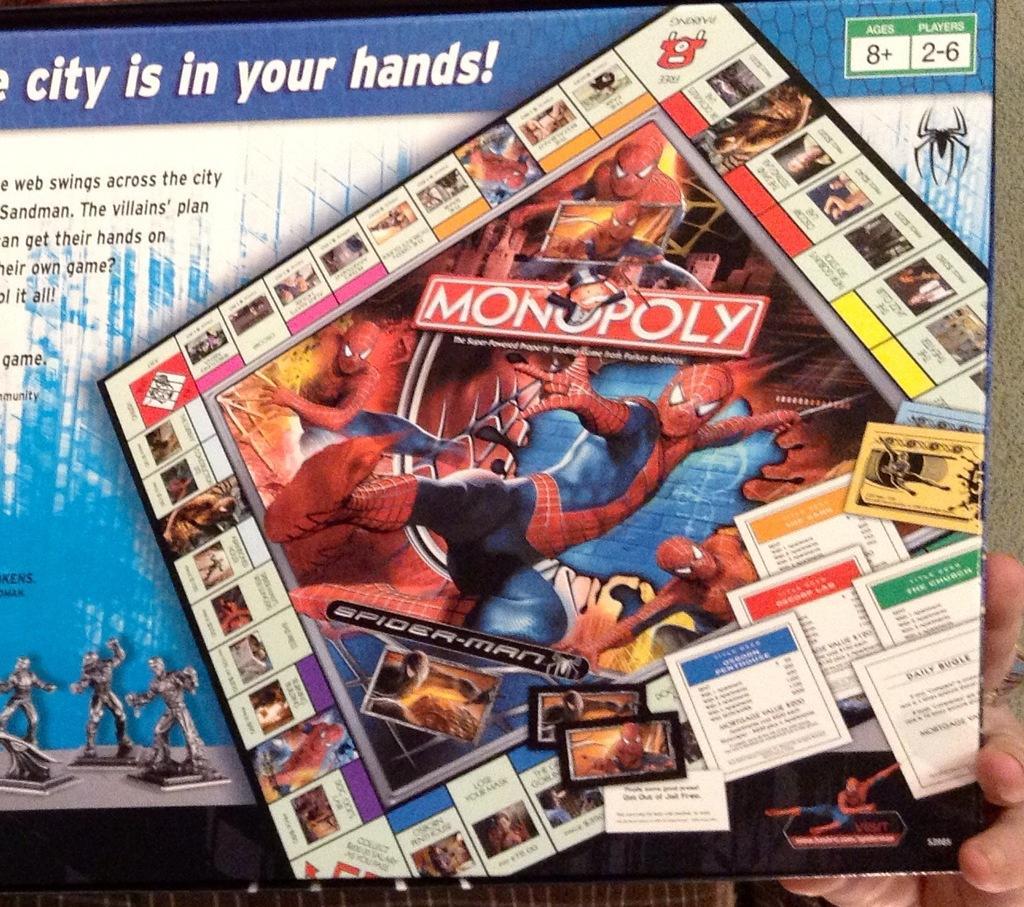Please provide a concise description of this image. In this image I can see a person's hand holding a box and on the box I can see the monopoly game and few spider man pictures. I can see the box is blue, black and white in color. 